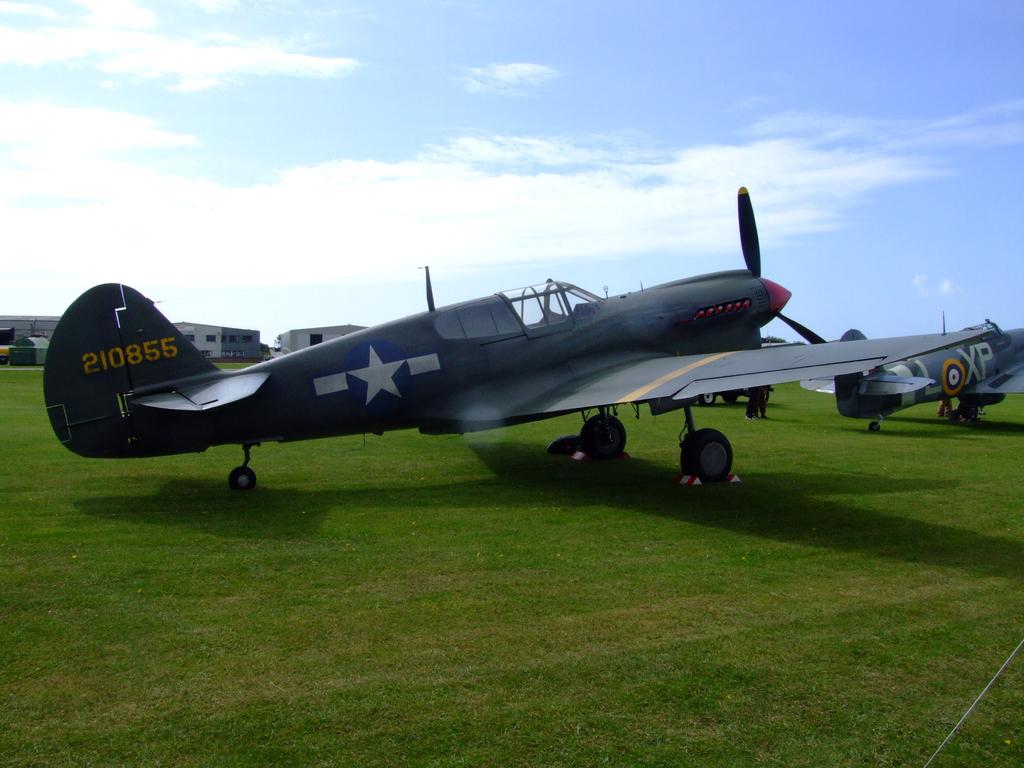What is this planes id number?
Keep it short and to the point. 210855. What letters are on the plane on the left?
Provide a succinct answer. 210855. 